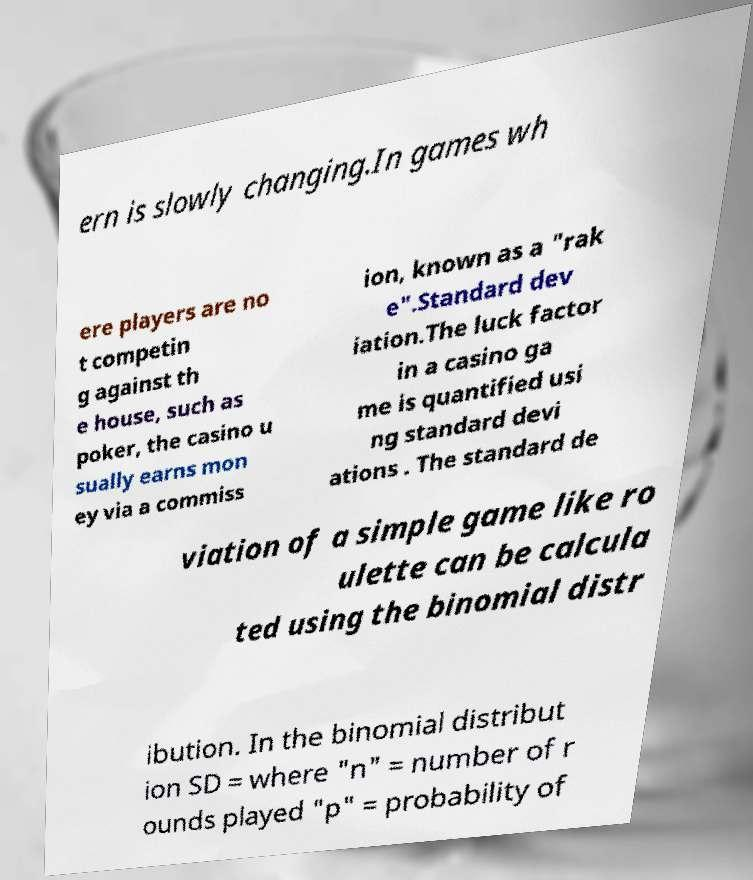There's text embedded in this image that I need extracted. Can you transcribe it verbatim? ern is slowly changing.In games wh ere players are no t competin g against th e house, such as poker, the casino u sually earns mon ey via a commiss ion, known as a "rak e".Standard dev iation.The luck factor in a casino ga me is quantified usi ng standard devi ations . The standard de viation of a simple game like ro ulette can be calcula ted using the binomial distr ibution. In the binomial distribut ion SD = where "n" = number of r ounds played "p" = probability of 